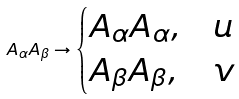<formula> <loc_0><loc_0><loc_500><loc_500>A _ { \alpha } A _ { \beta } \to \begin{cases} A _ { \alpha } A _ { \alpha } , & u \\ A _ { \beta } A _ { \beta } , & v \end{cases}</formula> 